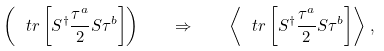<formula> <loc_0><loc_0><loc_500><loc_500>\left ( \ t r \left [ S ^ { \dagger } \frac { \tau ^ { a } } { 2 } S \tau ^ { b } \right ] \right ) \quad \Rightarrow \quad \left \langle \ t r \left [ S ^ { \dagger } \frac { \tau ^ { a } } { 2 } S \tau ^ { b } \right ] \right \rangle \, ,</formula> 